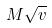<formula> <loc_0><loc_0><loc_500><loc_500>M \sqrt { v }</formula> 